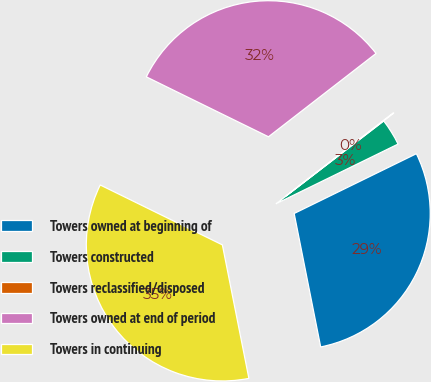Convert chart to OTSL. <chart><loc_0><loc_0><loc_500><loc_500><pie_chart><fcel>Towers owned at beginning of<fcel>Towers constructed<fcel>Towers reclassified/disposed<fcel>Towers owned at end of period<fcel>Towers in continuing<nl><fcel>29.12%<fcel>3.19%<fcel>0.06%<fcel>32.25%<fcel>35.38%<nl></chart> 